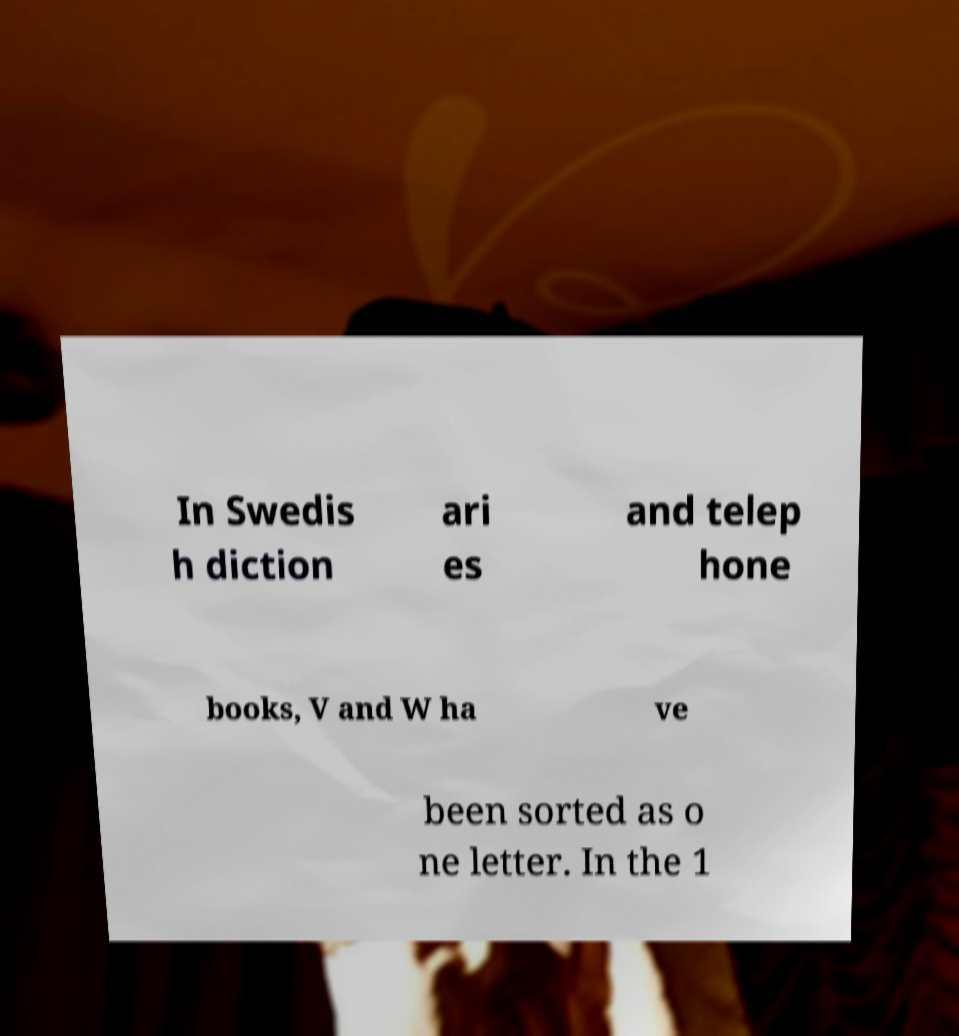Could you assist in decoding the text presented in this image and type it out clearly? In Swedis h diction ari es and telep hone books, V and W ha ve been sorted as o ne letter. In the 1 